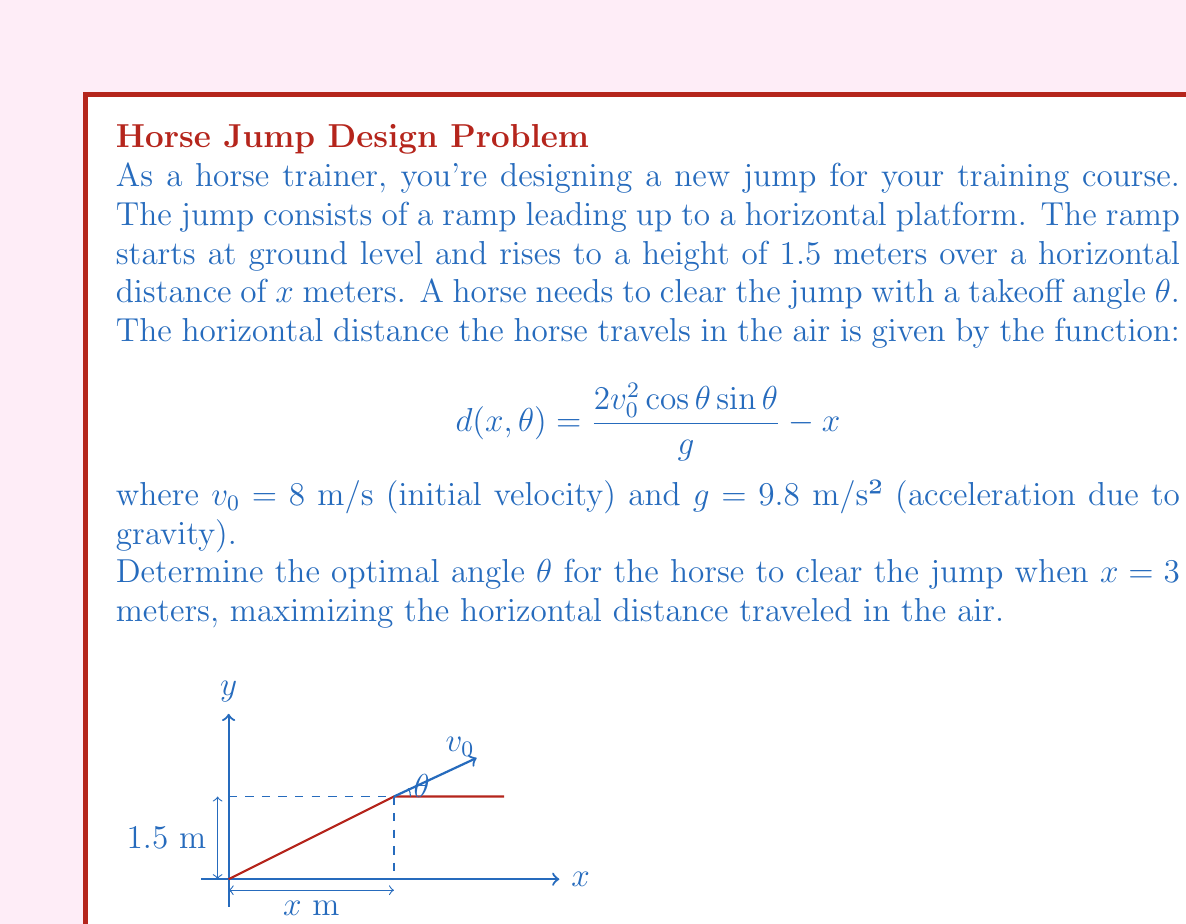Can you answer this question? To find the optimal angle, we need to maximize the function $d(x, \theta)$ with respect to $\theta$. We'll do this in steps:

1) First, let's simplify the given function by substituting the known values:
   $$d(\theta) = \frac{2(8^2) \cos\theta \sin\theta}{9.8} - 3$$
   $$d(\theta) = 13.0612 \cos\theta \sin\theta - 3$$

2) Recall the trigonometric identity: $\sin(2\theta) = 2\sin\theta\cos\theta$
   We can rewrite our function as:
   $$d(\theta) = 6.5306 \sin(2\theta) - 3$$

3) To find the maximum, we need to find where the derivative equals zero:
   $$\frac{d}{d\theta}[d(\theta)] = 13.0612 \cos(2\theta) = 0$$

4) Solving this equation:
   $$\cos(2\theta) = 0$$
   $$2\theta = \frac{\pi}{2}$$
   $$\theta = \frac{\pi}{4} = 45°$$

5) To confirm this is a maximum (not a minimum), we can check the second derivative:
   $$\frac{d^2}{d\theta^2}[d(\theta)] = -26.1224 \sin(2\theta)$$
   At $\theta = 45°$, this is negative, confirming a maximum.

Therefore, the optimal angle for the horse to clear the jump is 45°.
Answer: 45° 